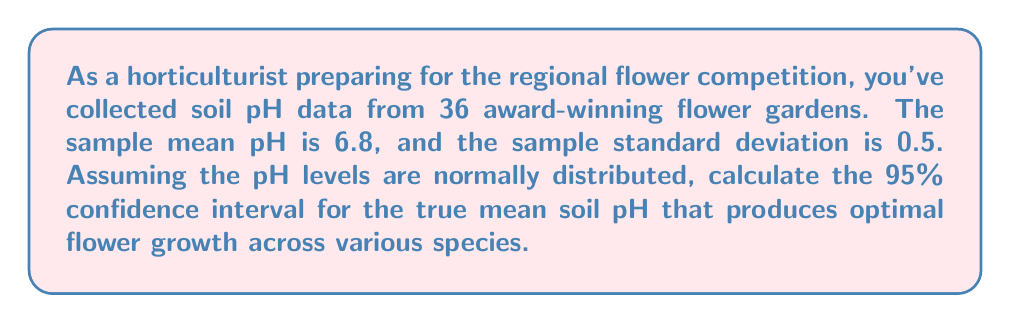Could you help me with this problem? To calculate the confidence interval, we'll use the formula:

$$ \text{CI} = \bar{x} \pm t_{\alpha/2} \cdot \frac{s}{\sqrt{n}} $$

Where:
$\bar{x}$ = sample mean = 6.8
$s$ = sample standard deviation = 0.5
$n$ = sample size = 36
$t_{\alpha/2}$ = t-value for 95% confidence level with 35 degrees of freedom

Steps:
1) Find $t_{\alpha/2}$:
   For 95% confidence and 35 df, $t_{\alpha/2}$ = 2.030 (from t-distribution table)

2) Calculate standard error:
   $SE = \frac{s}{\sqrt{n}} = \frac{0.5}{\sqrt{36}} = \frac{0.5}{6} = 0.0833$

3) Calculate margin of error:
   $ME = t_{\alpha/2} \cdot SE = 2.030 \cdot 0.0833 = 0.169$

4) Calculate confidence interval:
   $CI = 6.8 \pm 0.169$
   Lower bound: $6.8 - 0.169 = 6.631$
   Upper bound: $6.8 + 0.169 = 6.969$

Therefore, the 95% confidence interval for the true mean soil pH is (6.631, 6.969).
Answer: (6.631, 6.969) 